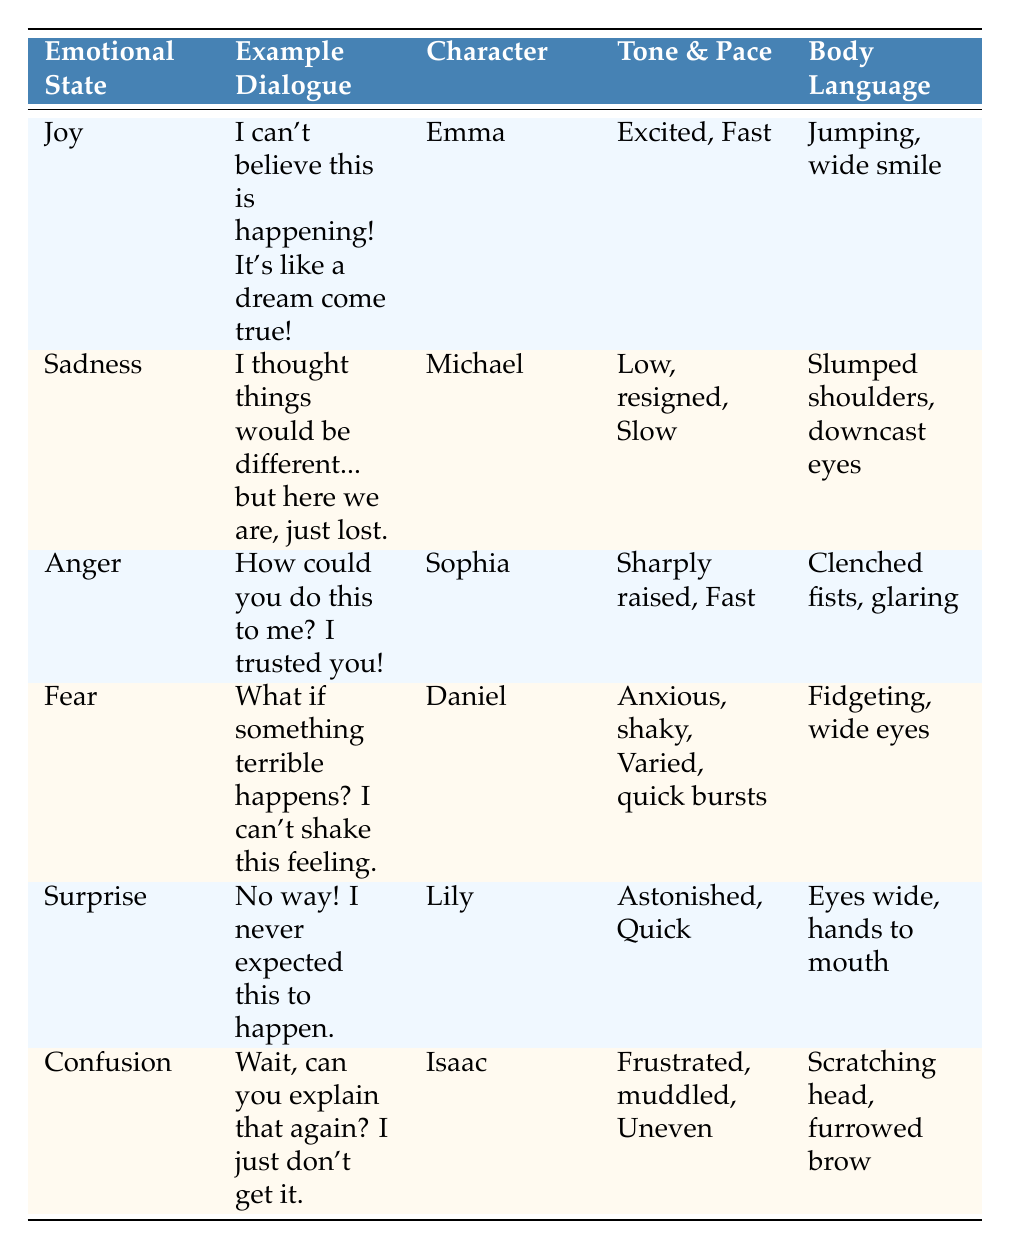What is the example dialogue for the emotional state of "Joy"? Looking at the table, I can find the row where the emotional state is "Joy." In that row, the example dialogue provided is "I can't believe this is happening! It's like a dream come true!"
Answer: I can't believe this is happening! It's like a dream come true! Which character expresses "Sadness"? By scanning the table, I see that the emotional state "Sadness" corresponds to the character "Michael."
Answer: Michael What tone and pace are associated with "Anger"? Referring to the table, in the row for "Anger," it indicates that the tone is "Sharply raised" and the pace is "Fast."
Answer: Sharply raised, Fast Is "Isaac" the character associated with the emotional state "Confusion"? The table lists "Isaac" as the character in the row where the emotional state is "Confusion," confirming this statement is true.
Answer: Yes What is the body language for the character in "Fear"? Looking at the row for "Fear," it shows that the body language described is "Fidgeting, wide eyes."
Answer: Fidgeting, wide eyes What emotional state has a character with a fast pace of dialogue? Analyzing the table, both "Joy" (Emma) and "Anger" (Sophia) have fast-paced dialogue. Therefore, the emotional states that match this criterion are "Joy" and "Anger."
Answer: Joy, Anger Which emotional states have body language indicating excitement? From the table, I can observe that the emotional state of "Joy," associated with Emma, shows body language that indicates excitement, which is "Jumping, wide smile." Thus, the only emotional state with this characteristic is "Joy."
Answer: Joy How many characters express a tone that is described as "Low, resigned"? In the table, I notice only one character, Michael, expresses a tone described as "Low, resigned," specifically for the emotional state "Sadness." Thus, the count is one character.
Answer: 1 What is the relationship between the emotional states "Fear" and "Surprise" in terms of body language? The body language for "Fear" (Daniel) is "Fidgeting, wide eyes," while the body language for "Surprise" (Lily) is "Eyes wide, hands to mouth." The common element is that both emotional states reflect heightened awareness or surprise, but the specific actions differ somewhat.
Answer: Both involve wide eyes, but actions differ 